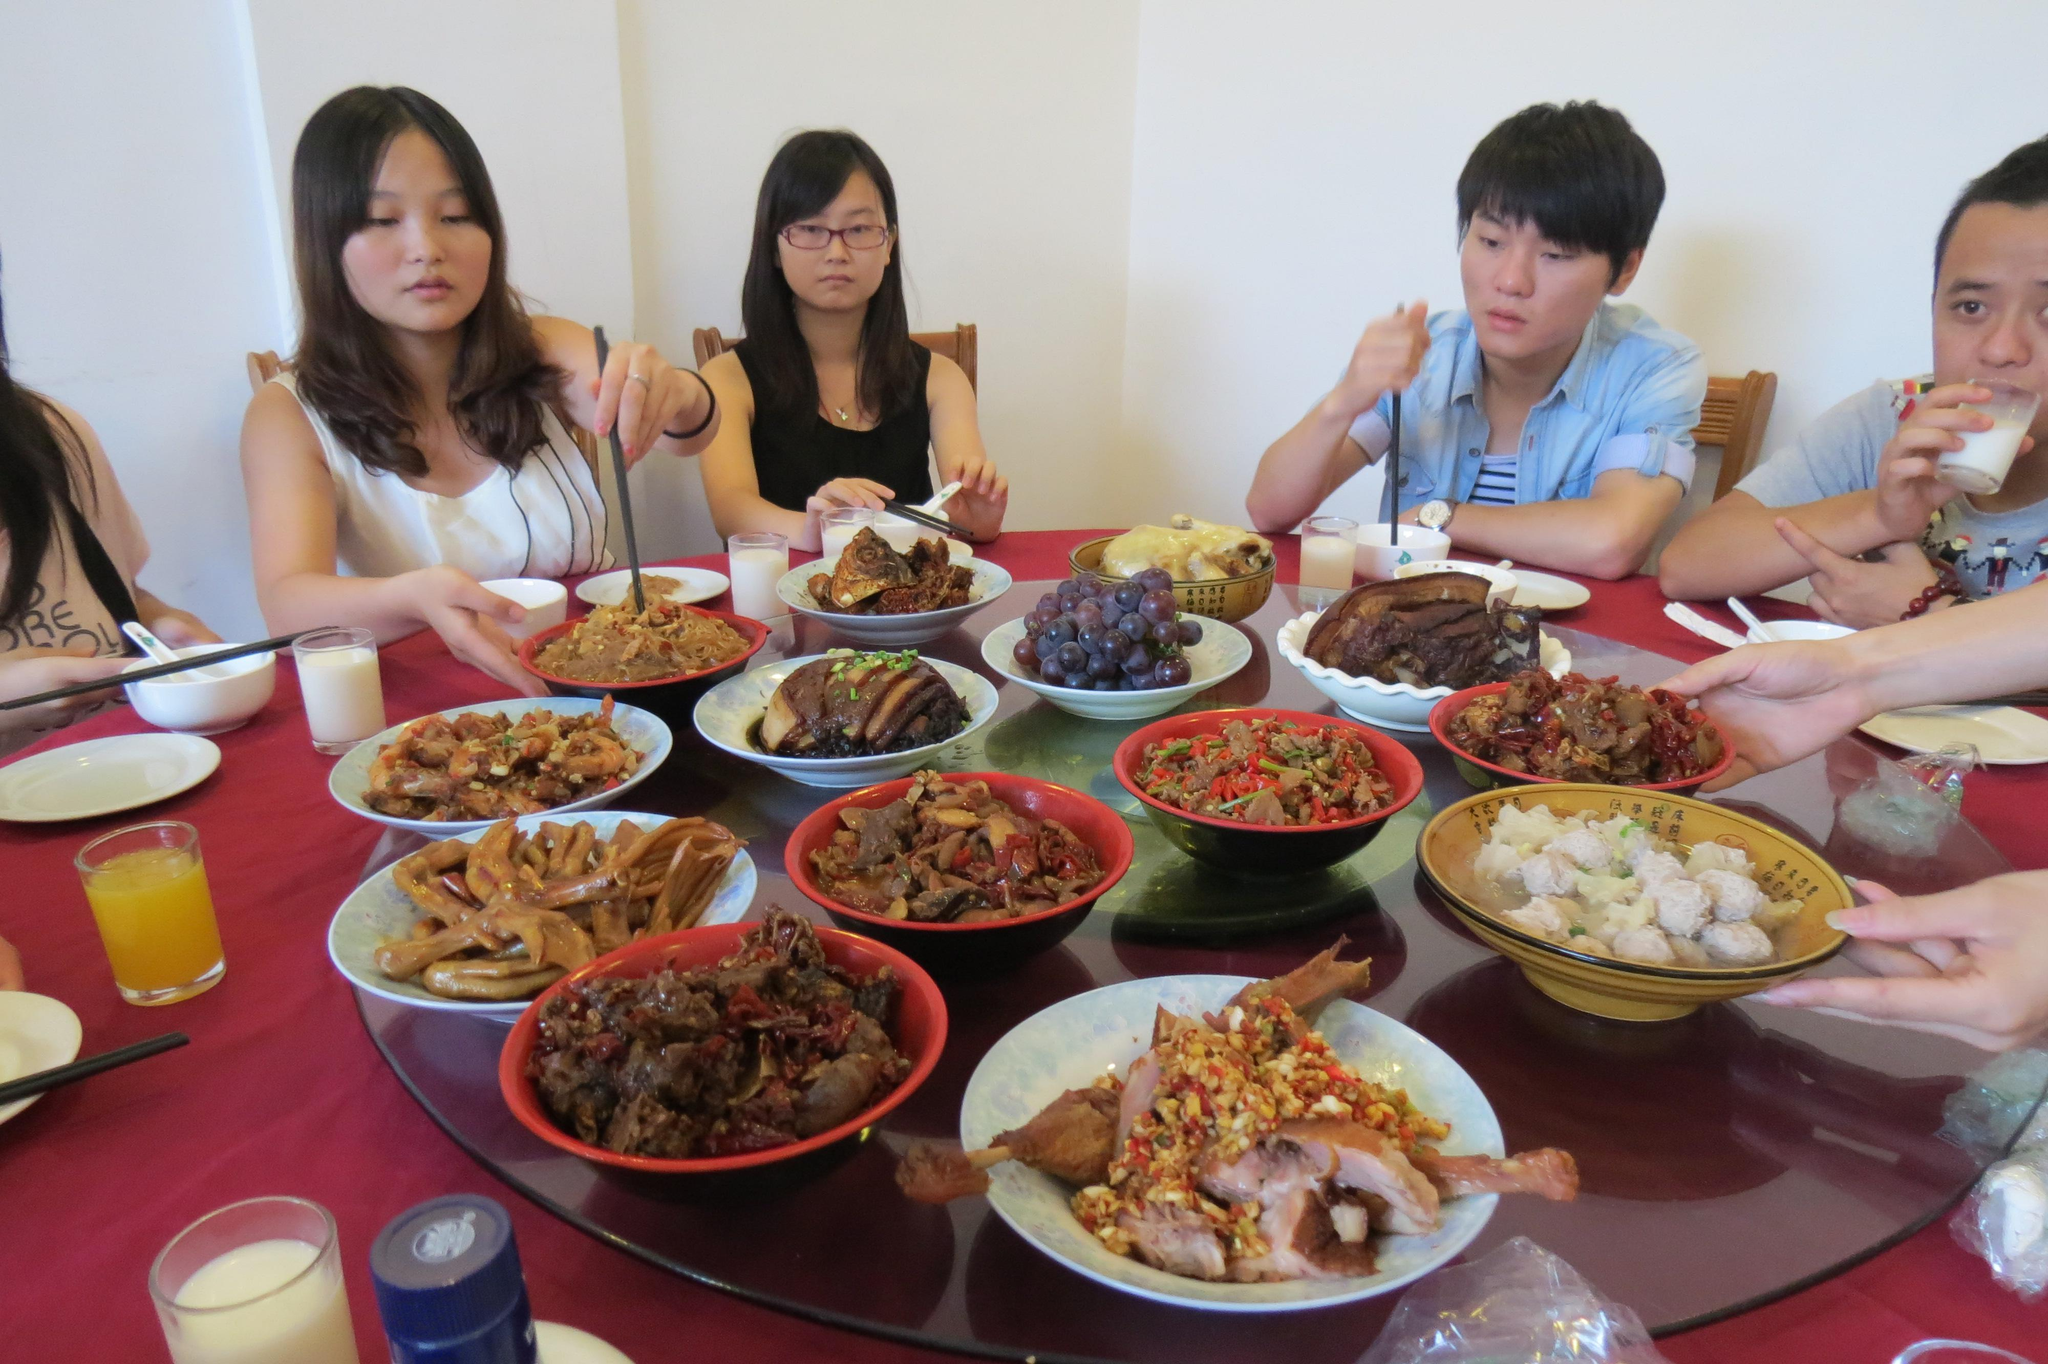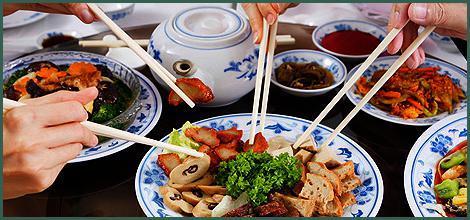The first image is the image on the left, the second image is the image on the right. Given the left and right images, does the statement "People are holding chopsticks in both images." hold true? Answer yes or no. Yes. The first image is the image on the left, the second image is the image on the right. Considering the images on both sides, is "In one of the images, four people are about to grab food from one plate, each using chop sticks." valid? Answer yes or no. Yes. 